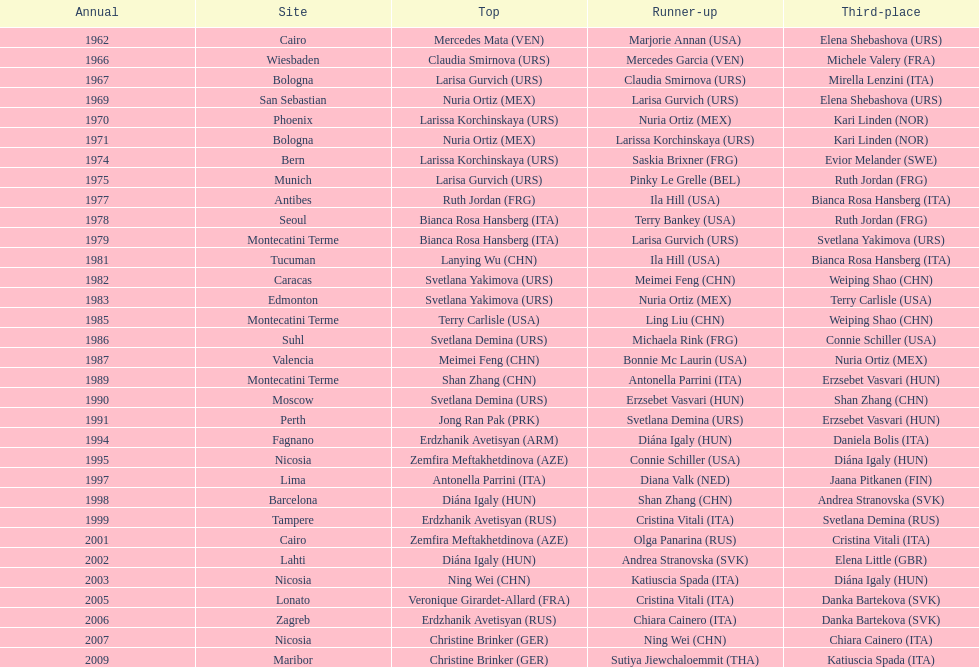How many gold did u.s.a win 1. 